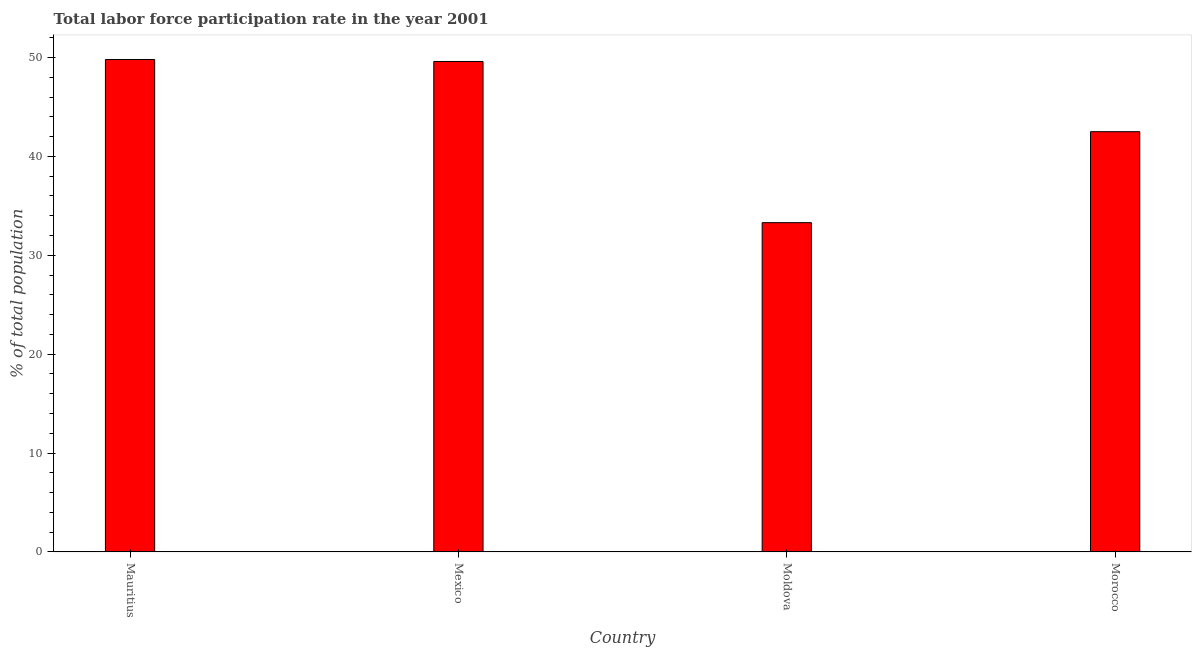Does the graph contain any zero values?
Provide a succinct answer. No. Does the graph contain grids?
Your answer should be compact. No. What is the title of the graph?
Provide a succinct answer. Total labor force participation rate in the year 2001. What is the label or title of the X-axis?
Provide a short and direct response. Country. What is the label or title of the Y-axis?
Ensure brevity in your answer.  % of total population. What is the total labor force participation rate in Morocco?
Your answer should be very brief. 42.5. Across all countries, what is the maximum total labor force participation rate?
Offer a very short reply. 49.8. Across all countries, what is the minimum total labor force participation rate?
Make the answer very short. 33.3. In which country was the total labor force participation rate maximum?
Your answer should be very brief. Mauritius. In which country was the total labor force participation rate minimum?
Give a very brief answer. Moldova. What is the sum of the total labor force participation rate?
Ensure brevity in your answer.  175.2. What is the average total labor force participation rate per country?
Provide a short and direct response. 43.8. What is the median total labor force participation rate?
Give a very brief answer. 46.05. What is the ratio of the total labor force participation rate in Mexico to that in Moldova?
Give a very brief answer. 1.49. Is the sum of the total labor force participation rate in Mexico and Moldova greater than the maximum total labor force participation rate across all countries?
Give a very brief answer. Yes. In how many countries, is the total labor force participation rate greater than the average total labor force participation rate taken over all countries?
Your answer should be very brief. 2. How many bars are there?
Ensure brevity in your answer.  4. Are the values on the major ticks of Y-axis written in scientific E-notation?
Provide a succinct answer. No. What is the % of total population in Mauritius?
Provide a short and direct response. 49.8. What is the % of total population of Mexico?
Ensure brevity in your answer.  49.6. What is the % of total population of Moldova?
Keep it short and to the point. 33.3. What is the % of total population in Morocco?
Make the answer very short. 42.5. What is the difference between the % of total population in Mauritius and Morocco?
Your answer should be compact. 7.3. What is the difference between the % of total population in Mexico and Moldova?
Offer a very short reply. 16.3. What is the ratio of the % of total population in Mauritius to that in Mexico?
Your answer should be compact. 1. What is the ratio of the % of total population in Mauritius to that in Moldova?
Ensure brevity in your answer.  1.5. What is the ratio of the % of total population in Mauritius to that in Morocco?
Your response must be concise. 1.17. What is the ratio of the % of total population in Mexico to that in Moldova?
Ensure brevity in your answer.  1.49. What is the ratio of the % of total population in Mexico to that in Morocco?
Your answer should be compact. 1.17. What is the ratio of the % of total population in Moldova to that in Morocco?
Keep it short and to the point. 0.78. 